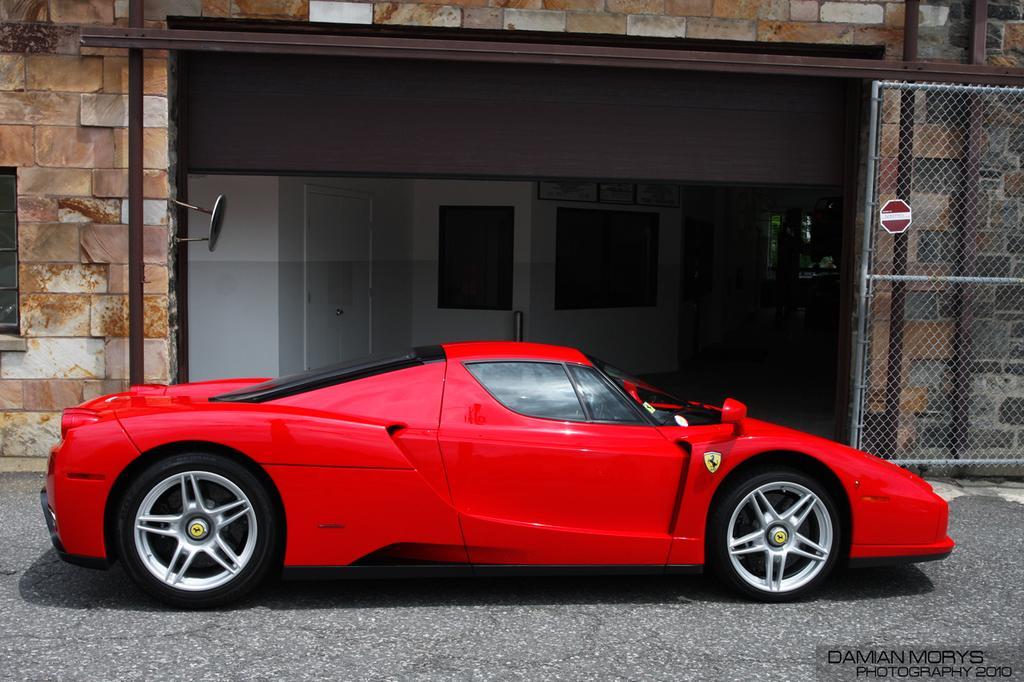Could you give a brief overview of what you see in this image? In this image, we can see a red car is parked on the road. Background we can see walls, window, door and few objects. On the right side of the image, we can see a sign board, mesh and watermark. 